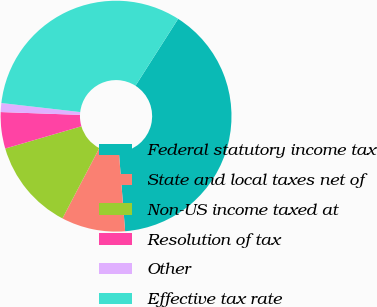<chart> <loc_0><loc_0><loc_500><loc_500><pie_chart><fcel>Federal statutory income tax<fcel>State and local taxes net of<fcel>Non-US income taxed at<fcel>Resolution of tax<fcel>Other<fcel>Effective tax rate<nl><fcel>39.71%<fcel>8.94%<fcel>12.79%<fcel>5.09%<fcel>1.25%<fcel>32.22%<nl></chart> 